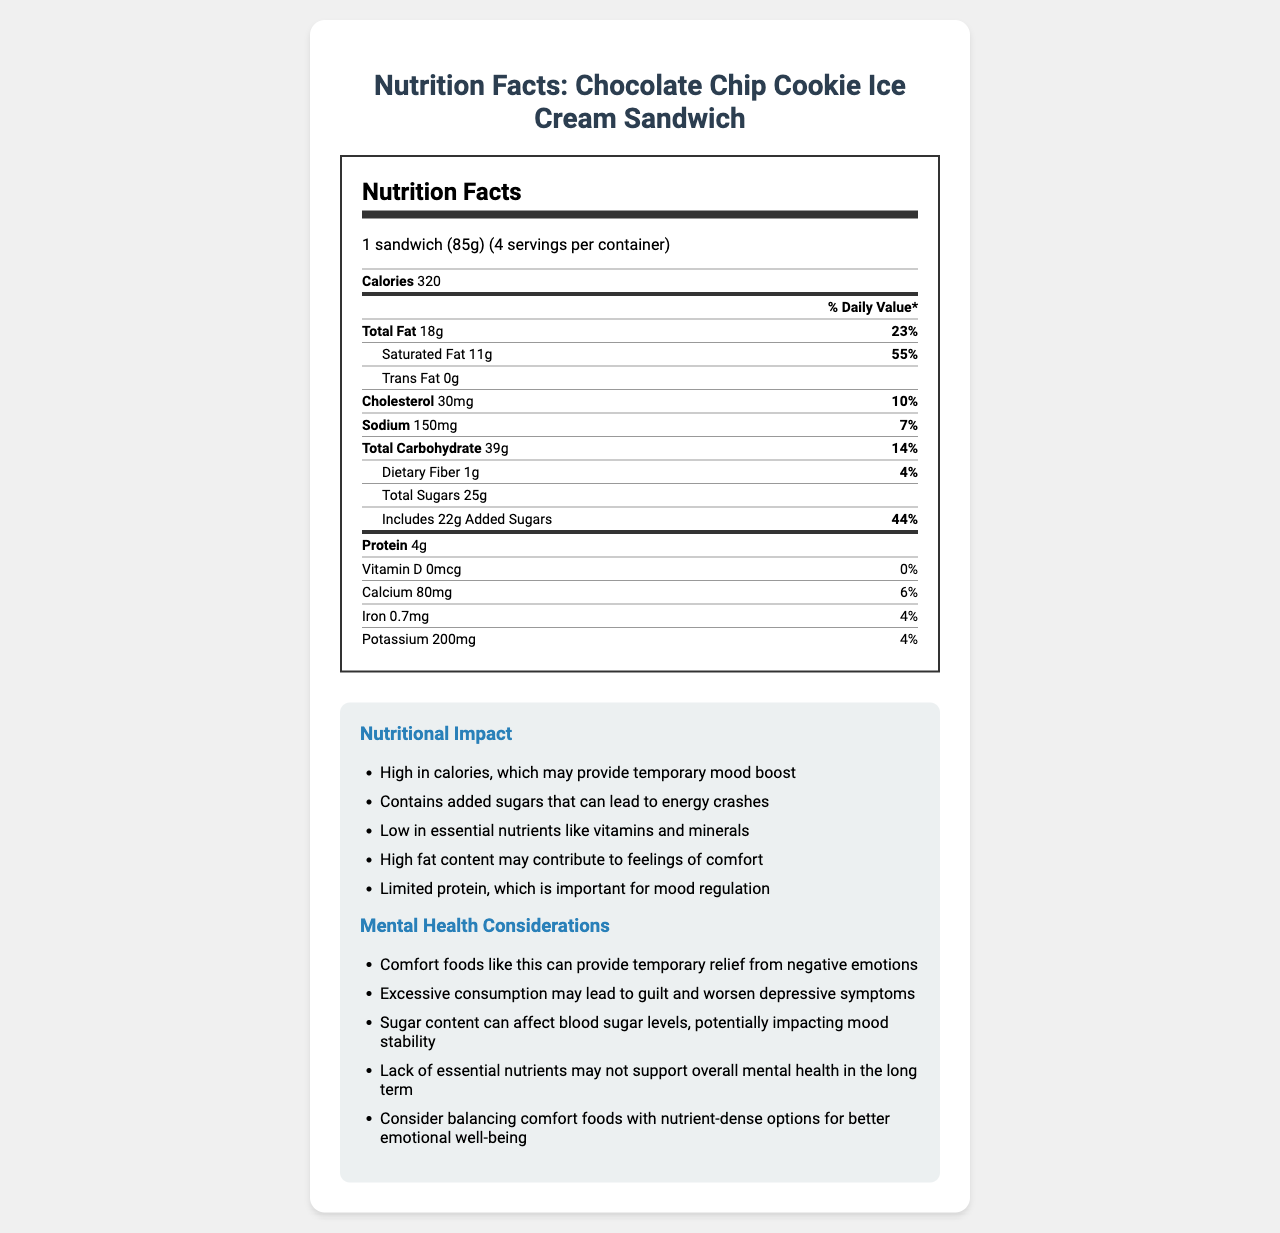what is the serving size for the Chocolate Chip Cookie Ice Cream Sandwich? The serving size is clearly labeled at the top of the Nutrition Facts label.
Answer: 1 sandwich (85g) how many calories are in one serving? The number of calories per serving is mentioned right under the serving size information.
Answer: 320 calories What is the total fat content in one sandwich? The total fat content is listed in the Nutrition Facts section under "Total Fat."
Answer: 18g how much of the daily value for saturated fat does one sandwich fulfil? The saturated fat percentage is listed next to the saturated fat amount.
Answer: 55% What is the amount of added sugars in one sandwich? The added sugars amount is shown in the Nutrition Facts under "Includes 22g Added Sugars."
Answer: 22g What is the percentage of daily value for calcium in one sandwich? The percentage of daily value for calcium is mentioned next to the calcium amount in the Vitamins and Minerals section.
Answer: 6% how many grams of protein are in one sandwich? The protein content is listed under the "Protein" section in the Nutrition Facts.
Answer: 4g which vitamin and mineral has a daily value of 0%? A. Iron B. Calcium C. Vitamin D The Vitamin D content at the bottom of the Nutrition Facts shows 0% daily value.
Answer: C. Vitamin D What is the impact of added sugars on mood stability? This information is provided in the Mental Health Considerations section.
Answer: Sugar content can affect blood sugar levels, potentially impacting mood stability excessive consumption of this comfort food may lead to what mental health outcome? The Mental Health Considerations section mentions that excessive consumption may lead to guilt and worsen depressive symptoms.
Answer: Worsen depressive symptoms Is this food high in cholesterol? The cholesterol content is 30 mg, which is 10% of the daily value, suggesting it is not high in cholesterol.
Answer: No which of the following is a consideration mentioned for balancing this comfort food? A. More exercise B. Nutrient-dense options C. More carbohydrates D. Reducing protein intake The Mental Health Considerations section suggests balancing comfort foods with nutrient-dense options.
Answer: B. Nutrient-dense options what is the main idea of this nutrition label? The document includes the Nutrition Facts label with serving size, calories, and nutritional content, along with notes on its nutritional impact and mental health considerations.
Answer: The document provides detailed nutritional information for the Chocolate Chip Cookie Ice Cream Sandwich, including calories, fats, sugars, and a discussion of its impact on nutrition and mental health. How does the carbohydrate content compare to the fiber content in one serving? The total carbohydrate and dietary fiber content are listed in the Nutrition Facts section, showing a significantly higher amount of total carbohydrates compared to dietary fiber.
Answer: 39g of total carbohydrates, 1g of dietary fiber Are there any essential vitamins present in the food? The Nutrition Facts section shows small percentages of calcium (6%), iron (4%), and potassium (4%), with no Vitamin D.
Answer: Yes, but in low amounts what ingredient is responsible for the energy crashes mentioned in the document? Added sugars, specifically the 22g of added sugars per sandwich, can lead to energy crashes, as mentioned in the nutritional impact section.
Answer: Added Sugars what percent of the daily value does sodium in one sandwich provide? The sodium content percentage (7%) is listed in the Nutrition Facts section.
Answer: 7% Does the document suggest that this comfort food is beneficial for long-term mental health? The Mental Health Considerations section mentions that lack of essential nutrients and excessive consumption may not support overall mental health in the long term.
Answer: No how many grams of total sugars are there in one serving? The total sugars content is found under the Total Sugars section in the Nutrition Facts.
Answer: 25g What is one reason this food might provide temporary relief from negative emotions? The nutritional impact section states that the high fat content may contribute to feelings of comfort and the high amount of added sugars can provide a temporary mood boost.
Answer: High fat content and added sugars do you think the label indicates if this food can help maintain a balanced diet? The label indicates that the food is high in calories, sugars, and fats, with limited essential nutrients, suggesting it may not help maintain a balanced diet in the long term.
Answer: No 